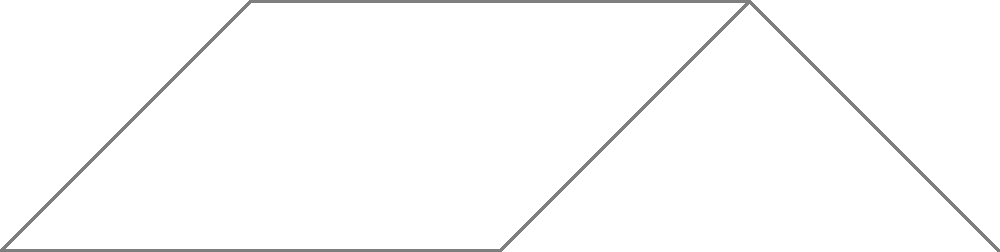In the context of international relations, consider the graph representing alliance structures between five countries (A, B, C, D, and E). The blue edges represent the minimum spanning tree of this alliance network. If country D were to leave the alliance network, how many distinct components would the remaining minimum spanning tree have? To solve this problem, we need to follow these steps:

1. Understand the current minimum spanning tree (MST):
   - The MST consists of the blue edges in the graph.
   - It connects all five countries (A, B, C, D, and E) with the minimum number of edges.

2. Identify the position of country D in the MST:
   - D is connected to B and E in the MST.
   - D acts as a bridge between these two parts of the tree.

3. Analyze the impact of removing D:
   - Removing D will break the connection between B and E.
   - This will split the MST into separate components.

4. Count the resulting components:
   - Component 1: A - B
   - Component 2: C
   - Component 3: E

5. Conclude:
   - After removing D, the remaining MST will have 3 distinct components.

This analysis is crucial in understanding how the removal of a key diplomatic player (country D) can fragment the alliance structure, potentially leading to a less cohesive international framework.
Answer: 3 components 